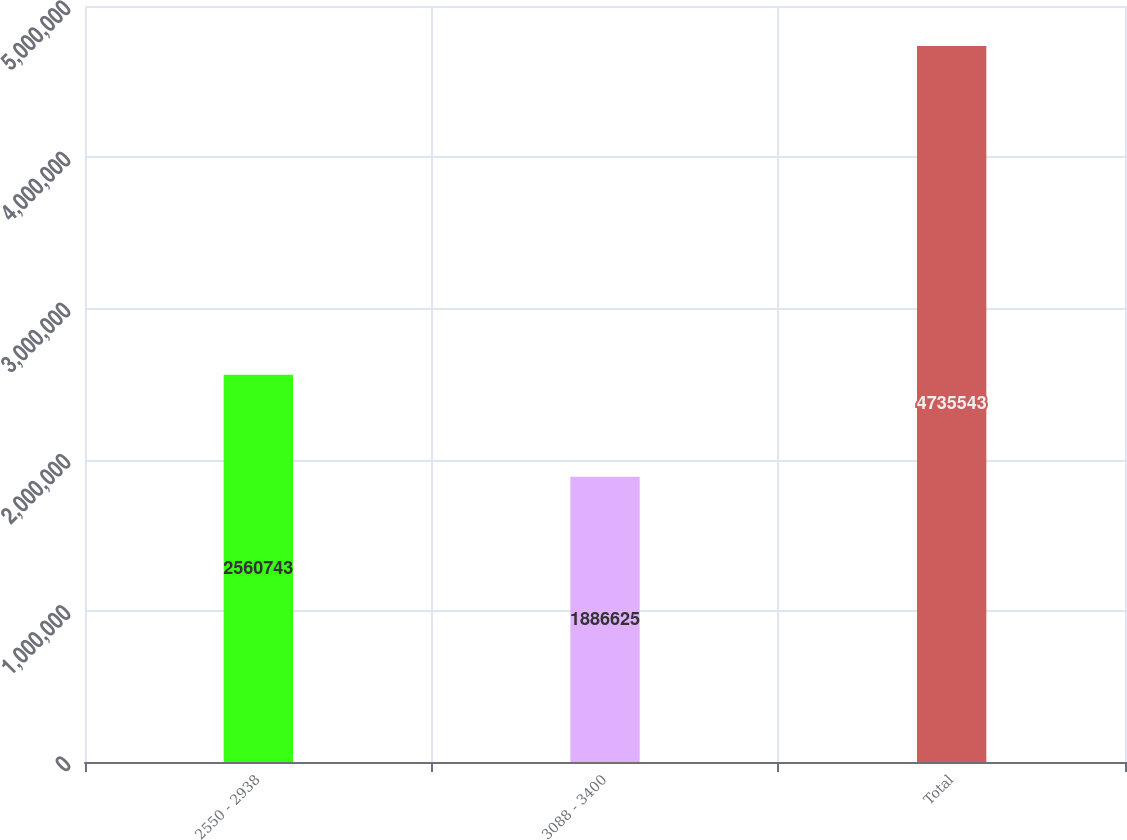<chart> <loc_0><loc_0><loc_500><loc_500><bar_chart><fcel>2550 - 2938<fcel>3088 - 3400<fcel>Total<nl><fcel>2.56074e+06<fcel>1.88662e+06<fcel>4.73554e+06<nl></chart> 